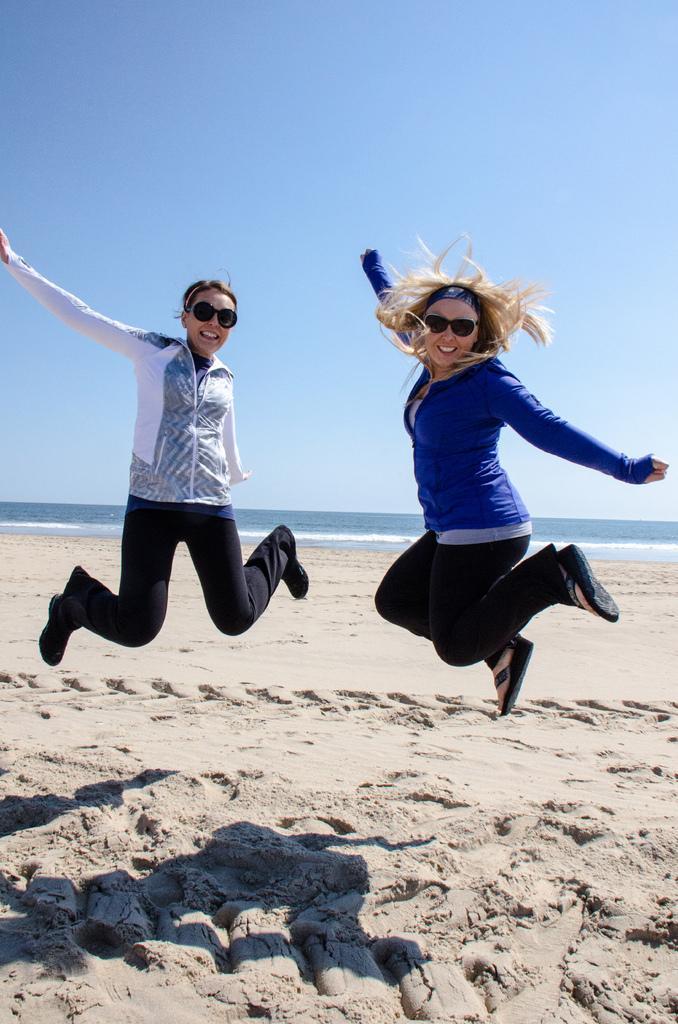How would you summarize this image in a sentence or two? In this image there are two women jumping in the air. There is sand on the ground. They are smiling. Behind them there is water. At the top there is the sky. 